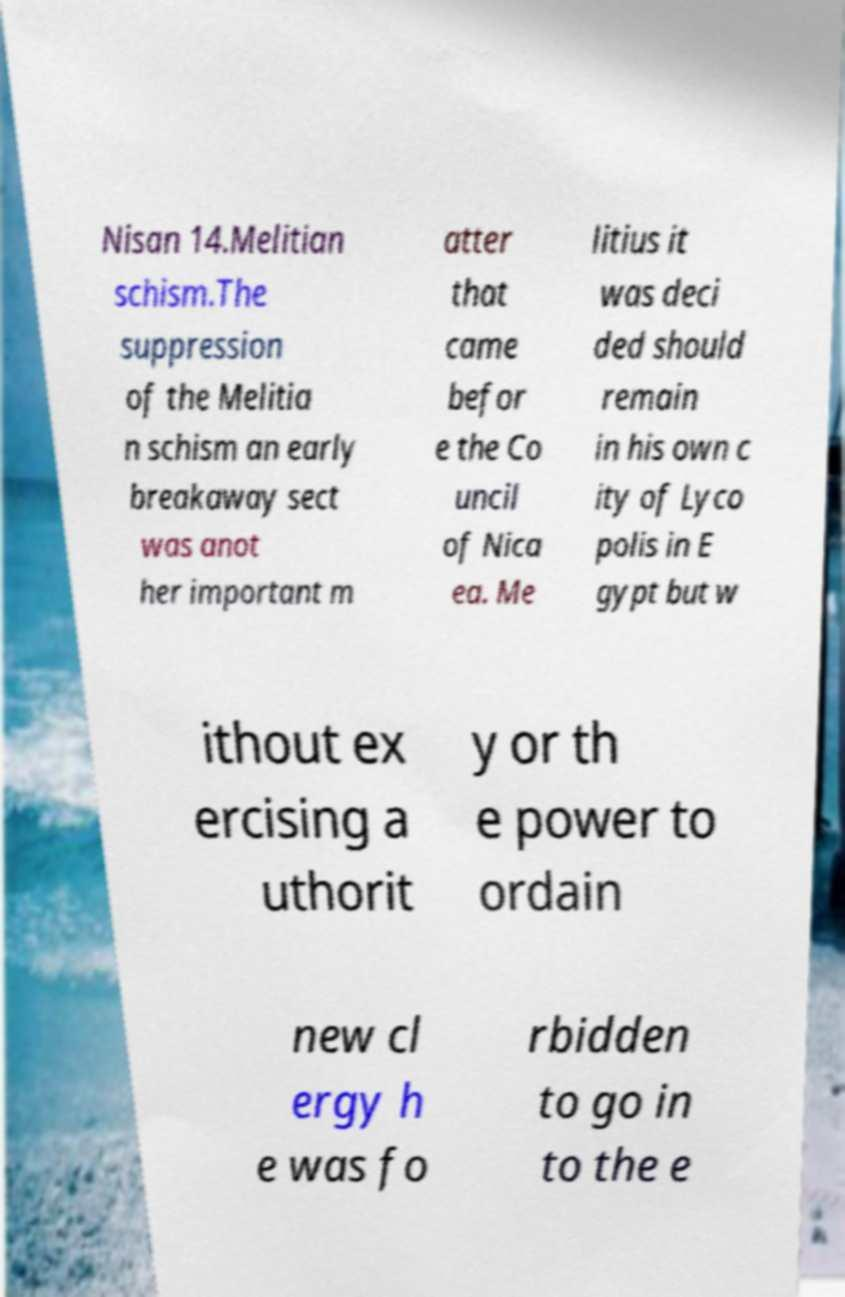Please read and relay the text visible in this image. What does it say? Nisan 14.Melitian schism.The suppression of the Melitia n schism an early breakaway sect was anot her important m atter that came befor e the Co uncil of Nica ea. Me litius it was deci ded should remain in his own c ity of Lyco polis in E gypt but w ithout ex ercising a uthorit y or th e power to ordain new cl ergy h e was fo rbidden to go in to the e 